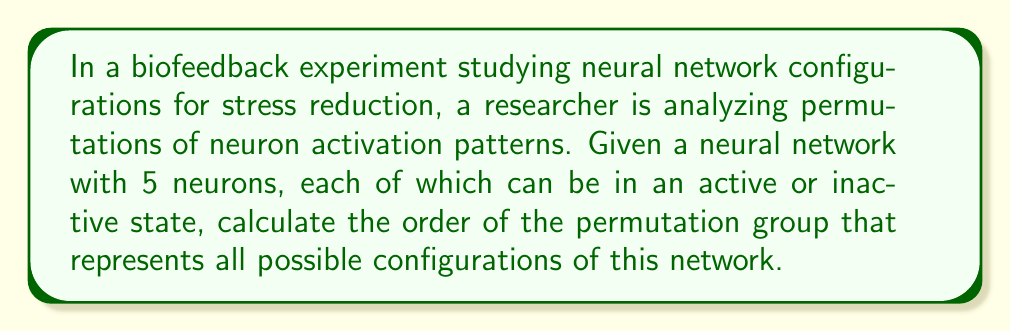Teach me how to tackle this problem. To solve this problem, we need to follow these steps:

1. Determine the number of possible states for each neuron:
   Each neuron can be in one of two states: active or inactive. This means there are 2 possibilities for each neuron.

2. Calculate the total number of possible configurations:
   With 5 neurons, each having 2 possible states, the total number of configurations is:
   $$2^5 = 32$$

3. Understand the permutation group:
   The permutation group in this context represents all possible ways to rearrange these 32 configurations. This is equivalent to the symmetric group on 32 elements, denoted as $S_{32}$.

4. Calculate the order of the permutation group:
   The order of a symmetric group $S_n$ is given by $n!$. In this case, we need to calculate:
   $$|S_{32}| = 32!$$

5. Compute the final result:
   $$32! = 2.6313 \times 10^{35}$$

This large number represents the total number of ways to permute the different activation patterns in the neural network, which could be relevant in understanding the complexity of neural responses in biofeedback interventions for stress reduction.
Answer: The order of the permutation group representing all possible configurations of the 5-neuron network is $32! = 2.6313 \times 10^{35}$. 